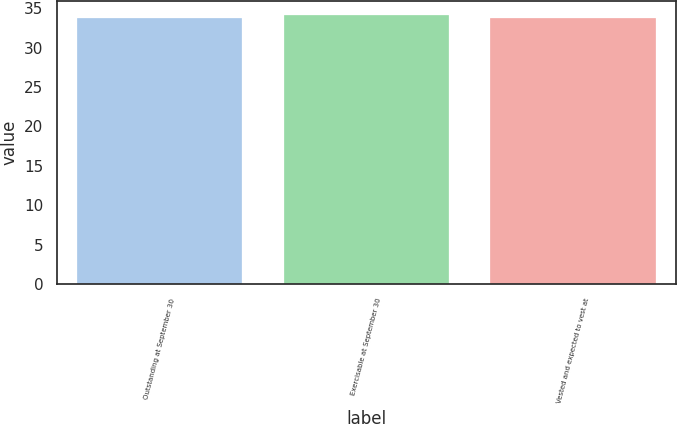Convert chart to OTSL. <chart><loc_0><loc_0><loc_500><loc_500><bar_chart><fcel>Outstanding at September 30<fcel>Exercisable at September 30<fcel>Vested and expected to vest at<nl><fcel>33.75<fcel>34.17<fcel>33.79<nl></chart> 